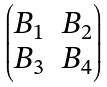<formula> <loc_0><loc_0><loc_500><loc_500>\begin{pmatrix} B _ { 1 } & B _ { 2 } \\ B _ { 3 } & B _ { 4 } \end{pmatrix}</formula> 